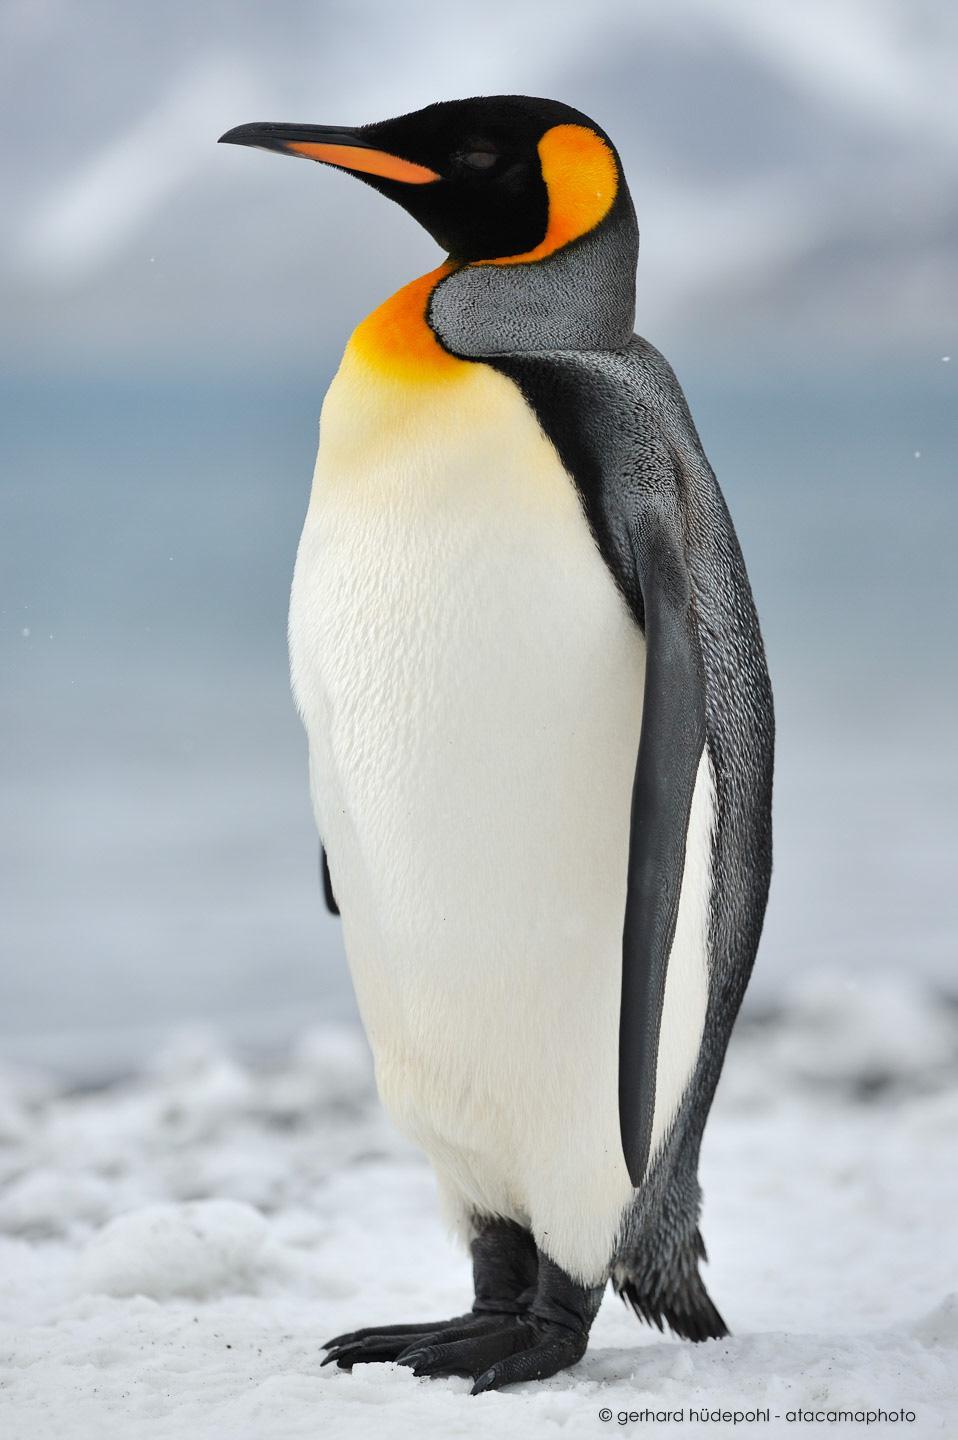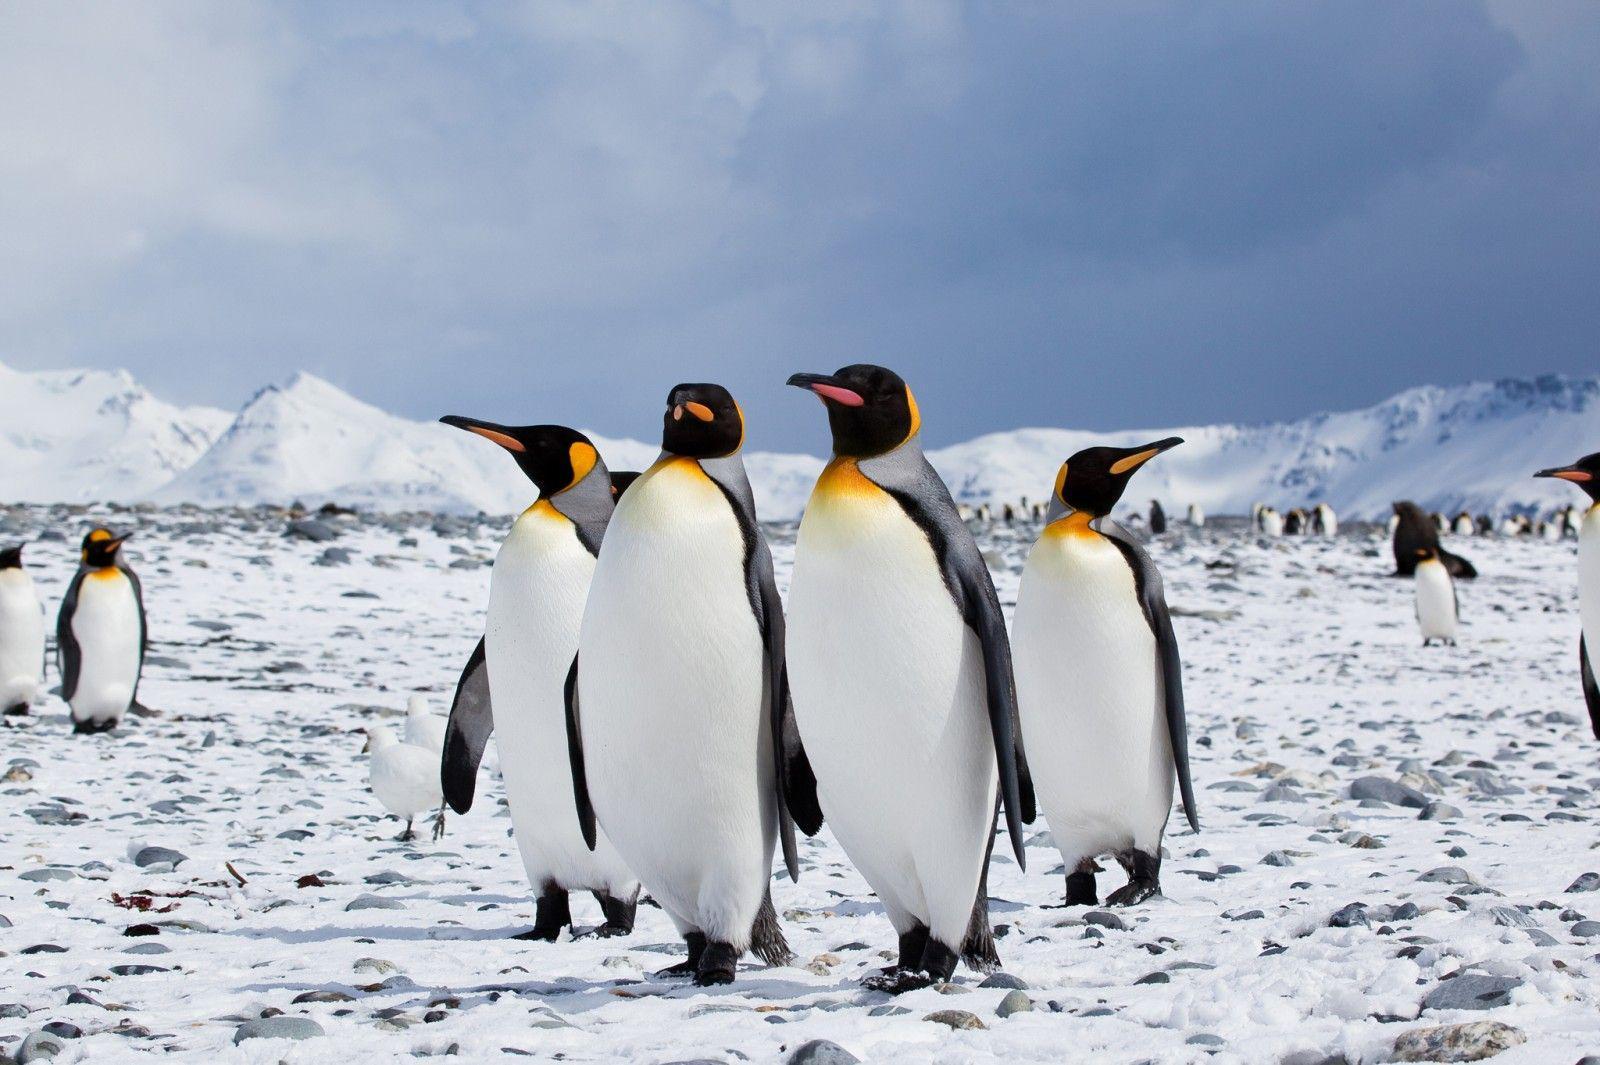The first image is the image on the left, the second image is the image on the right. For the images shown, is this caption "There is only one penguin in each image and every penguin looks towards the right." true? Answer yes or no. No. The first image is the image on the left, the second image is the image on the right. For the images shown, is this caption "Each image contains one standing penguin, and all penguins have heads turned rightward." true? Answer yes or no. No. 